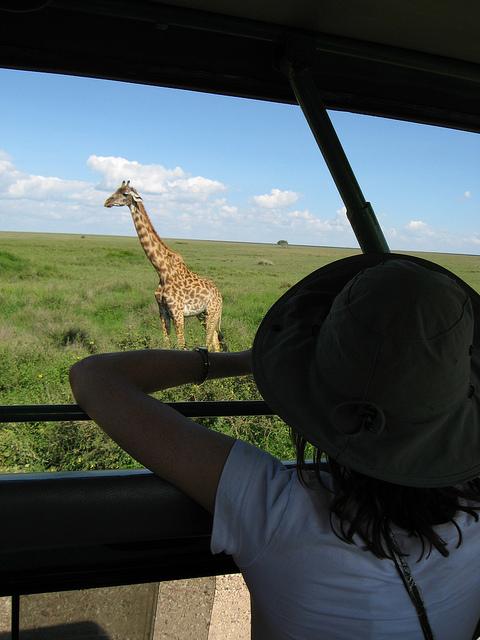What type of animal is the person looking at?
Keep it brief. Giraffe. Is the girl wearing a hat?
Short answer required. Yes. Do you think this picture was taken in the United States?
Answer briefly. No. 